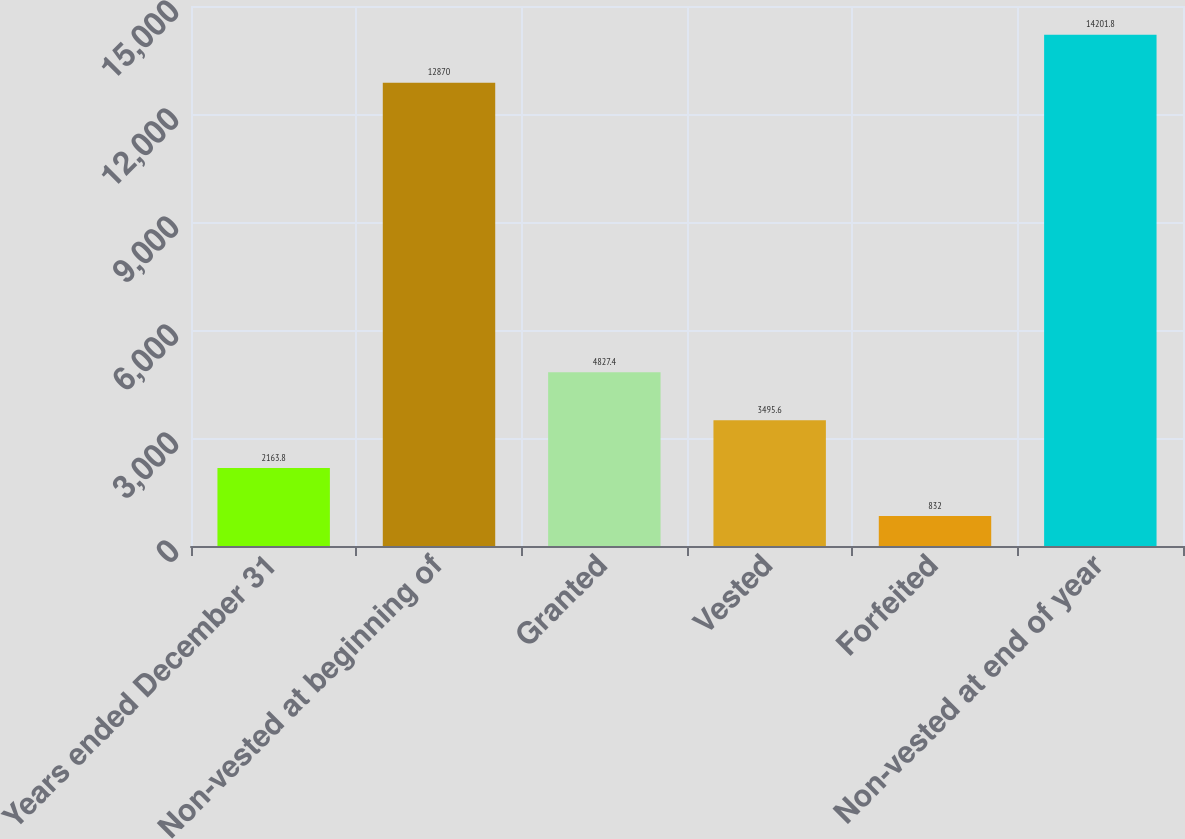<chart> <loc_0><loc_0><loc_500><loc_500><bar_chart><fcel>Years ended December 31<fcel>Non-vested at beginning of<fcel>Granted<fcel>Vested<fcel>Forfeited<fcel>Non-vested at end of year<nl><fcel>2163.8<fcel>12870<fcel>4827.4<fcel>3495.6<fcel>832<fcel>14201.8<nl></chart> 